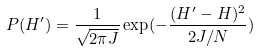Convert formula to latex. <formula><loc_0><loc_0><loc_500><loc_500>P ( H ^ { \prime } ) = \frac { 1 } { \sqrt { 2 \pi J } } \exp ( - \frac { ( H ^ { \prime } - H ) ^ { 2 } } { 2 J / N } )</formula> 